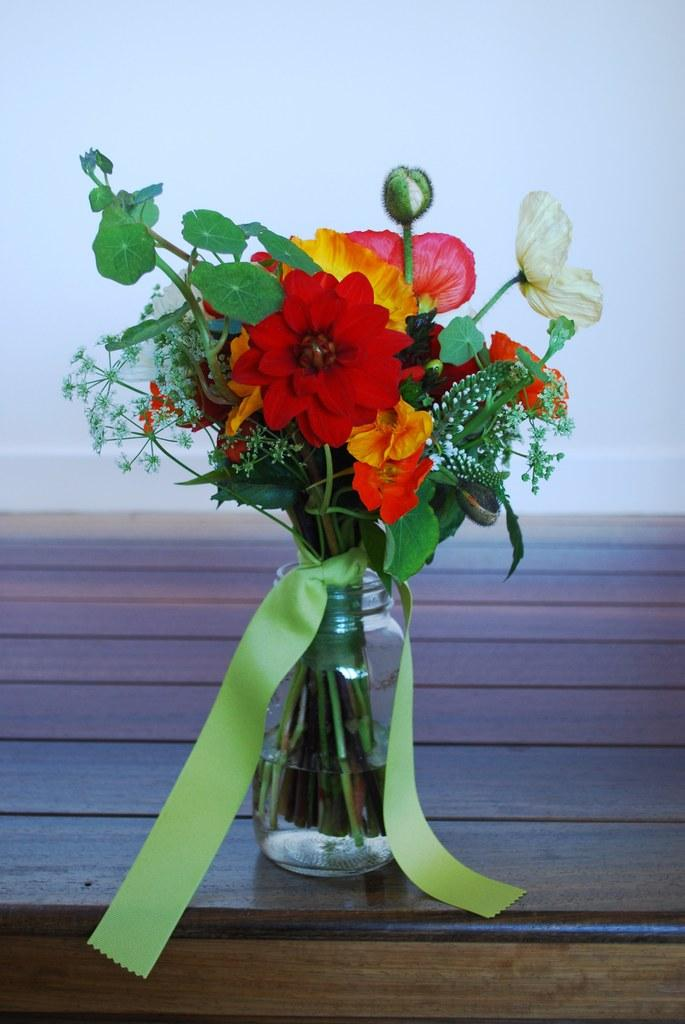What object is present in the image that typically holds flowers? There is a flower vase in the image. Where is the flower vase located? The flower vase is on a table. What time of day is depicted in the image? The provided facts do not mention the time of day, so it cannot be determined from the image. 